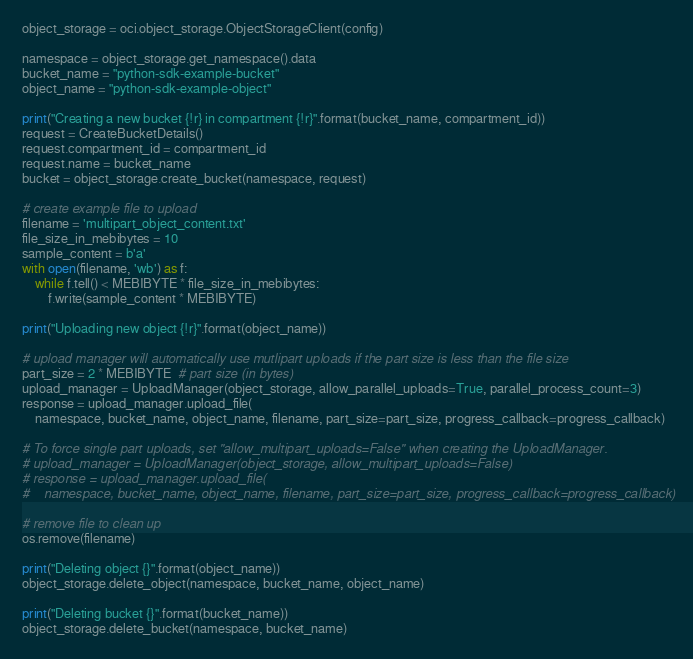Convert code to text. <code><loc_0><loc_0><loc_500><loc_500><_Python_>object_storage = oci.object_storage.ObjectStorageClient(config)

namespace = object_storage.get_namespace().data
bucket_name = "python-sdk-example-bucket"
object_name = "python-sdk-example-object"

print("Creating a new bucket {!r} in compartment {!r}".format(bucket_name, compartment_id))
request = CreateBucketDetails()
request.compartment_id = compartment_id
request.name = bucket_name
bucket = object_storage.create_bucket(namespace, request)

# create example file to upload
filename = 'multipart_object_content.txt'
file_size_in_mebibytes = 10
sample_content = b'a'
with open(filename, 'wb') as f:
    while f.tell() < MEBIBYTE * file_size_in_mebibytes:
        f.write(sample_content * MEBIBYTE)

print("Uploading new object {!r}".format(object_name))

# upload manager will automatically use mutlipart uploads if the part size is less than the file size
part_size = 2 * MEBIBYTE  # part size (in bytes)
upload_manager = UploadManager(object_storage, allow_parallel_uploads=True, parallel_process_count=3)
response = upload_manager.upload_file(
    namespace, bucket_name, object_name, filename, part_size=part_size, progress_callback=progress_callback)

# To force single part uploads, set "allow_multipart_uploads=False" when creating the UploadManager.
# upload_manager = UploadManager(object_storage, allow_multipart_uploads=False)
# response = upload_manager.upload_file(
#    namespace, bucket_name, object_name, filename, part_size=part_size, progress_callback=progress_callback)

# remove file to clean up
os.remove(filename)

print("Deleting object {}".format(object_name))
object_storage.delete_object(namespace, bucket_name, object_name)

print("Deleting bucket {}".format(bucket_name))
object_storage.delete_bucket(namespace, bucket_name)
</code> 